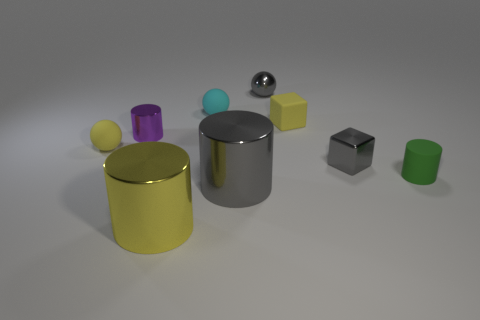The small metallic cube has what color?
Offer a terse response. Gray. What is the shape of the tiny object that is on the right side of the small gray shiny object right of the small yellow matte block?
Your answer should be compact. Cylinder. Are there any purple cylinders that have the same material as the yellow cylinder?
Provide a succinct answer. Yes. There is a gray thing left of the gray metal ball; is its size the same as the small yellow rubber ball?
Give a very brief answer. No. What number of gray objects are shiny spheres or shiny blocks?
Offer a terse response. 2. What is the tiny ball in front of the tiny cyan thing made of?
Offer a terse response. Rubber. How many tiny green cylinders are behind the metal cylinder that is behind the matte cylinder?
Your answer should be very brief. 0. How many brown shiny things are the same shape as the large gray metallic object?
Provide a succinct answer. 0. How many big metallic things are there?
Provide a succinct answer. 2. There is a small matte thing to the left of the large yellow metallic object; what color is it?
Provide a short and direct response. Yellow. 